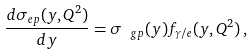Convert formula to latex. <formula><loc_0><loc_0><loc_500><loc_500>\frac { d \sigma _ { e p } ( y , Q ^ { 2 } ) } { d y } = \sigma _ { \ g p } ( y ) f _ { \gamma / e } ( y , Q ^ { 2 } ) \, ,</formula> 